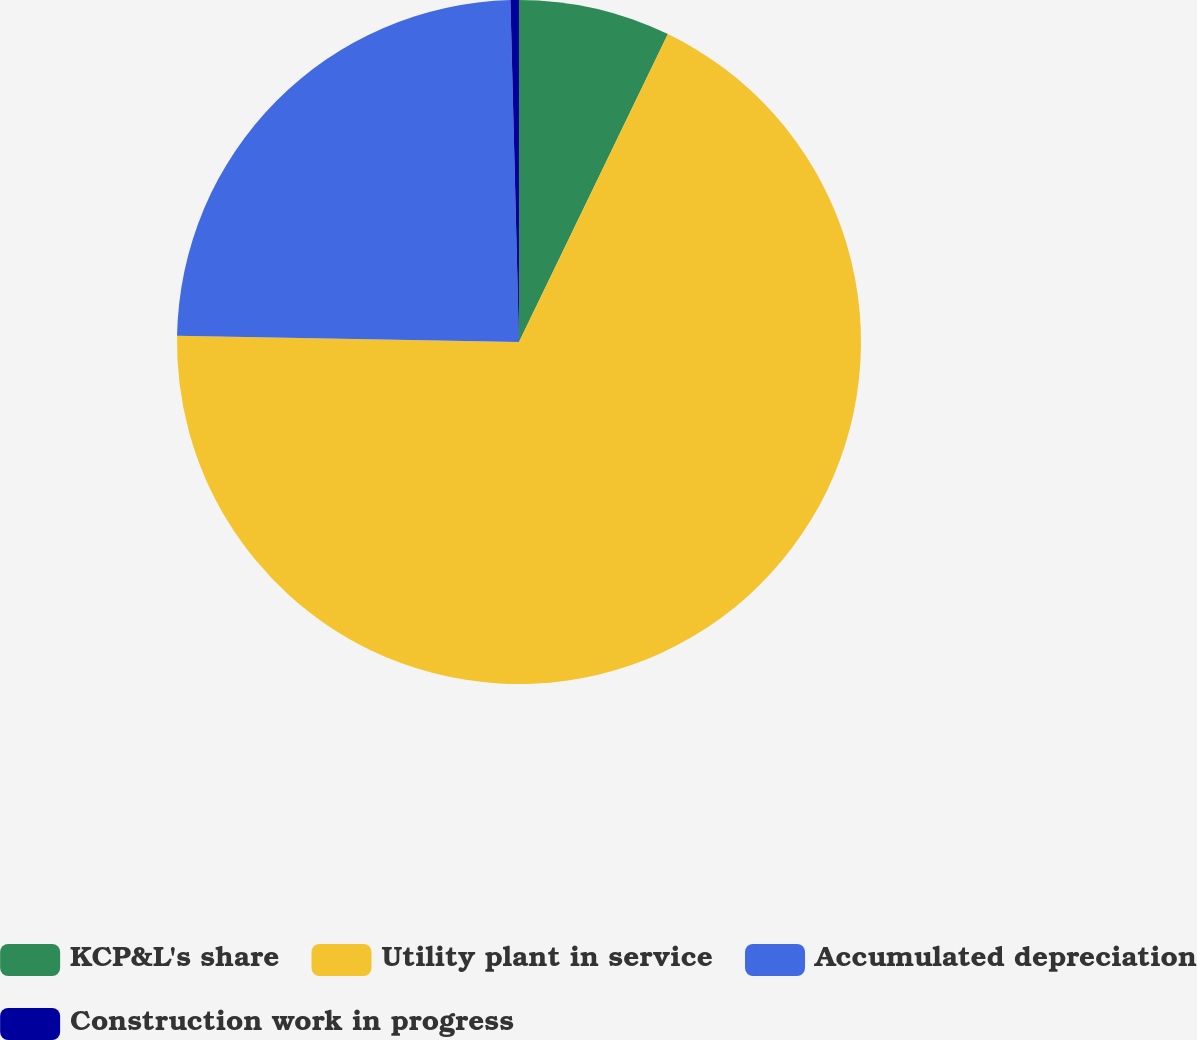Convert chart to OTSL. <chart><loc_0><loc_0><loc_500><loc_500><pie_chart><fcel>KCP&L's share<fcel>Utility plant in service<fcel>Accumulated depreciation<fcel>Construction work in progress<nl><fcel>7.17%<fcel>68.12%<fcel>24.31%<fcel>0.4%<nl></chart> 